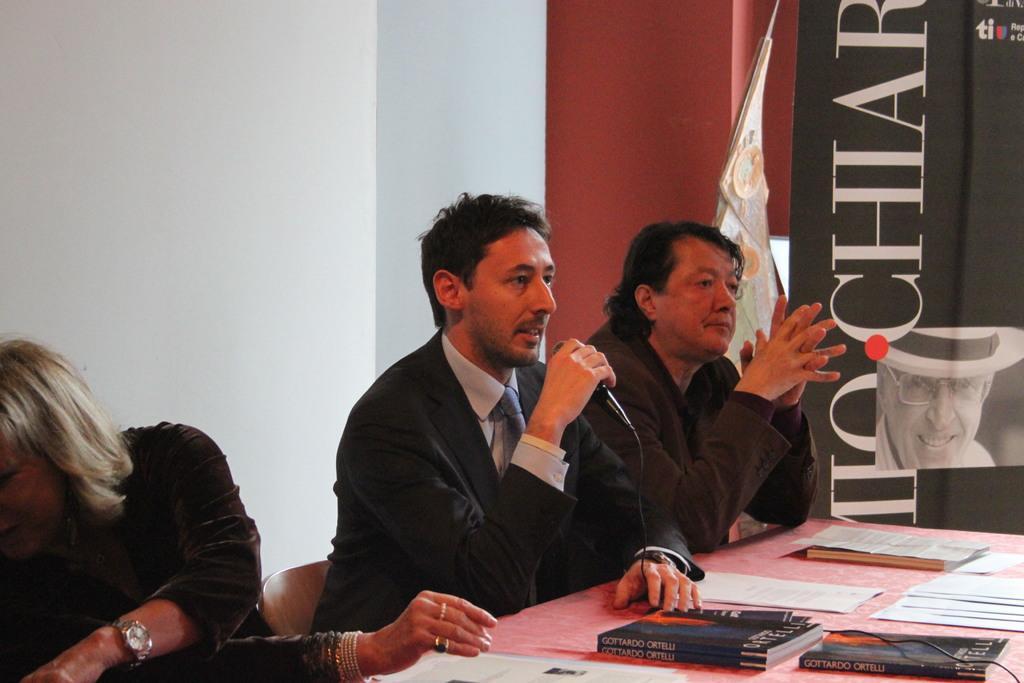Describe this image in one or two sentences. In this image we can see three people sitting on the chairs. In that a man is holding a mic. We can also see a table containing some books and papers on it. On the backside we can see a wall with some text and the picture of a person on it. 